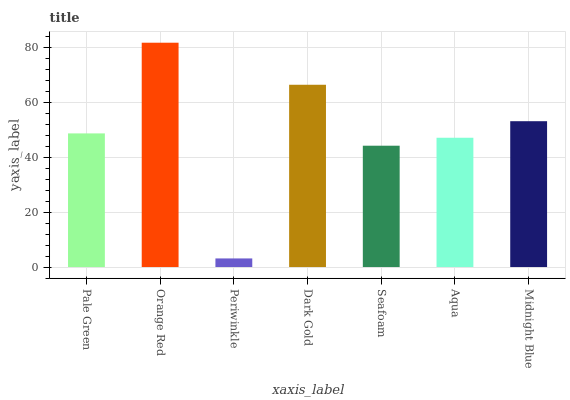Is Orange Red the minimum?
Answer yes or no. No. Is Periwinkle the maximum?
Answer yes or no. No. Is Orange Red greater than Periwinkle?
Answer yes or no. Yes. Is Periwinkle less than Orange Red?
Answer yes or no. Yes. Is Periwinkle greater than Orange Red?
Answer yes or no. No. Is Orange Red less than Periwinkle?
Answer yes or no. No. Is Pale Green the high median?
Answer yes or no. Yes. Is Pale Green the low median?
Answer yes or no. Yes. Is Seafoam the high median?
Answer yes or no. No. Is Dark Gold the low median?
Answer yes or no. No. 